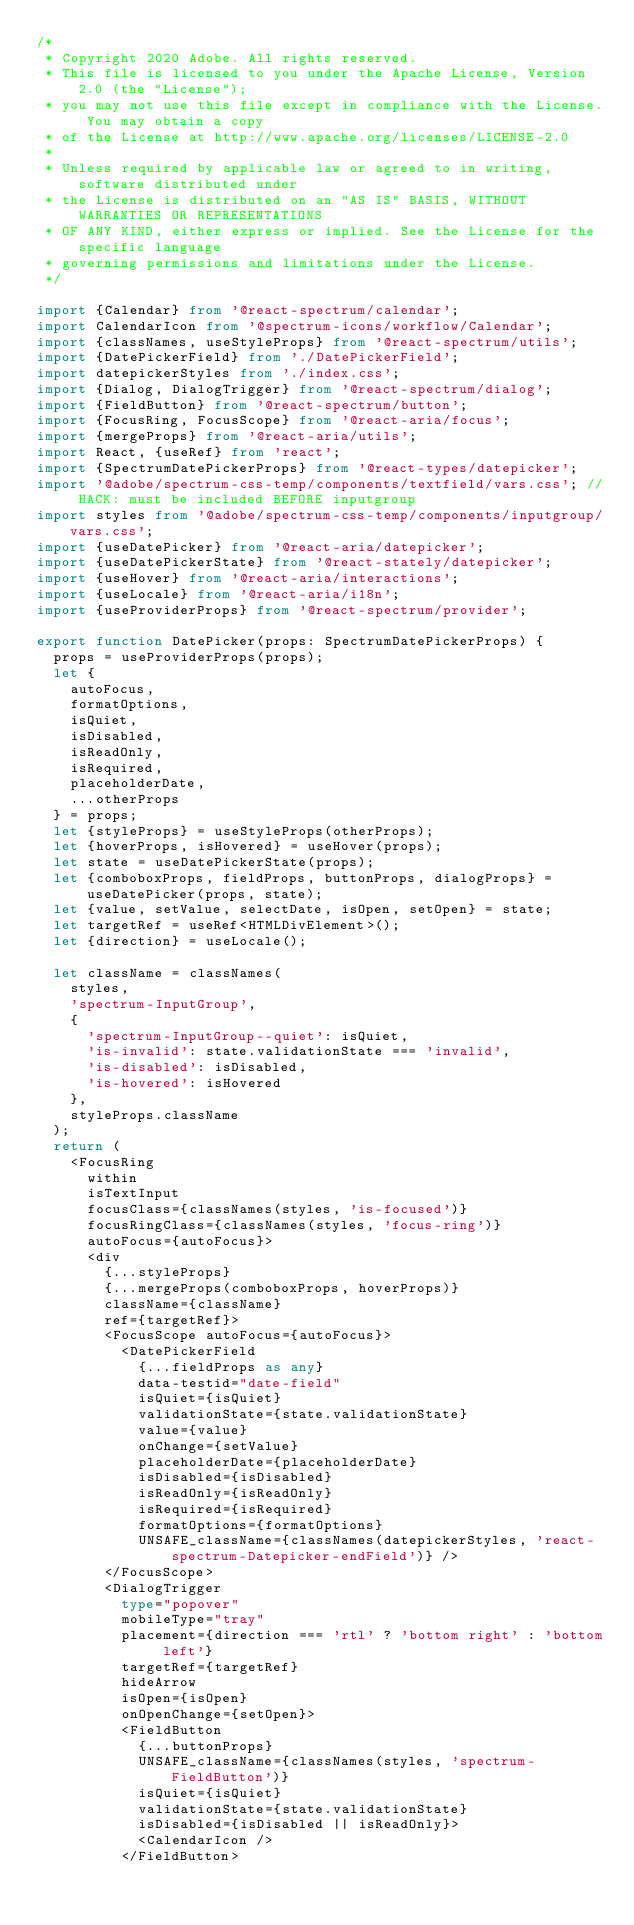<code> <loc_0><loc_0><loc_500><loc_500><_TypeScript_>/*
 * Copyright 2020 Adobe. All rights reserved.
 * This file is licensed to you under the Apache License, Version 2.0 (the "License");
 * you may not use this file except in compliance with the License. You may obtain a copy
 * of the License at http://www.apache.org/licenses/LICENSE-2.0
 *
 * Unless required by applicable law or agreed to in writing, software distributed under
 * the License is distributed on an "AS IS" BASIS, WITHOUT WARRANTIES OR REPRESENTATIONS
 * OF ANY KIND, either express or implied. See the License for the specific language
 * governing permissions and limitations under the License.
 */

import {Calendar} from '@react-spectrum/calendar';
import CalendarIcon from '@spectrum-icons/workflow/Calendar';
import {classNames, useStyleProps} from '@react-spectrum/utils';
import {DatePickerField} from './DatePickerField';
import datepickerStyles from './index.css';
import {Dialog, DialogTrigger} from '@react-spectrum/dialog';
import {FieldButton} from '@react-spectrum/button';
import {FocusRing, FocusScope} from '@react-aria/focus';
import {mergeProps} from '@react-aria/utils';
import React, {useRef} from 'react';
import {SpectrumDatePickerProps} from '@react-types/datepicker';
import '@adobe/spectrum-css-temp/components/textfield/vars.css'; // HACK: must be included BEFORE inputgroup
import styles from '@adobe/spectrum-css-temp/components/inputgroup/vars.css';
import {useDatePicker} from '@react-aria/datepicker';
import {useDatePickerState} from '@react-stately/datepicker';
import {useHover} from '@react-aria/interactions';
import {useLocale} from '@react-aria/i18n';
import {useProviderProps} from '@react-spectrum/provider';

export function DatePicker(props: SpectrumDatePickerProps) {
  props = useProviderProps(props);
  let {
    autoFocus,
    formatOptions,
    isQuiet,
    isDisabled,
    isReadOnly,
    isRequired,
    placeholderDate,
    ...otherProps
  } = props;
  let {styleProps} = useStyleProps(otherProps);
  let {hoverProps, isHovered} = useHover(props);
  let state = useDatePickerState(props);
  let {comboboxProps, fieldProps, buttonProps, dialogProps} = useDatePicker(props, state);
  let {value, setValue, selectDate, isOpen, setOpen} = state;
  let targetRef = useRef<HTMLDivElement>();
  let {direction} = useLocale();

  let className = classNames(
    styles,
    'spectrum-InputGroup',
    {
      'spectrum-InputGroup--quiet': isQuiet,
      'is-invalid': state.validationState === 'invalid',
      'is-disabled': isDisabled,
      'is-hovered': isHovered
    },
    styleProps.className
  );
  return (
    <FocusRing
      within
      isTextInput
      focusClass={classNames(styles, 'is-focused')}
      focusRingClass={classNames(styles, 'focus-ring')}
      autoFocus={autoFocus}>
      <div
        {...styleProps}
        {...mergeProps(comboboxProps, hoverProps)}
        className={className}
        ref={targetRef}>
        <FocusScope autoFocus={autoFocus}>
          <DatePickerField
            {...fieldProps as any}
            data-testid="date-field"
            isQuiet={isQuiet}
            validationState={state.validationState}
            value={value}
            onChange={setValue}
            placeholderDate={placeholderDate}
            isDisabled={isDisabled}
            isReadOnly={isReadOnly}
            isRequired={isRequired}
            formatOptions={formatOptions}
            UNSAFE_className={classNames(datepickerStyles, 'react-spectrum-Datepicker-endField')} />
        </FocusScope>
        <DialogTrigger
          type="popover"
          mobileType="tray"
          placement={direction === 'rtl' ? 'bottom right' : 'bottom left'}
          targetRef={targetRef}
          hideArrow
          isOpen={isOpen}
          onOpenChange={setOpen}>
          <FieldButton
            {...buttonProps}
            UNSAFE_className={classNames(styles, 'spectrum-FieldButton')}
            isQuiet={isQuiet}
            validationState={state.validationState}
            isDisabled={isDisabled || isReadOnly}>
            <CalendarIcon />
          </FieldButton></code> 